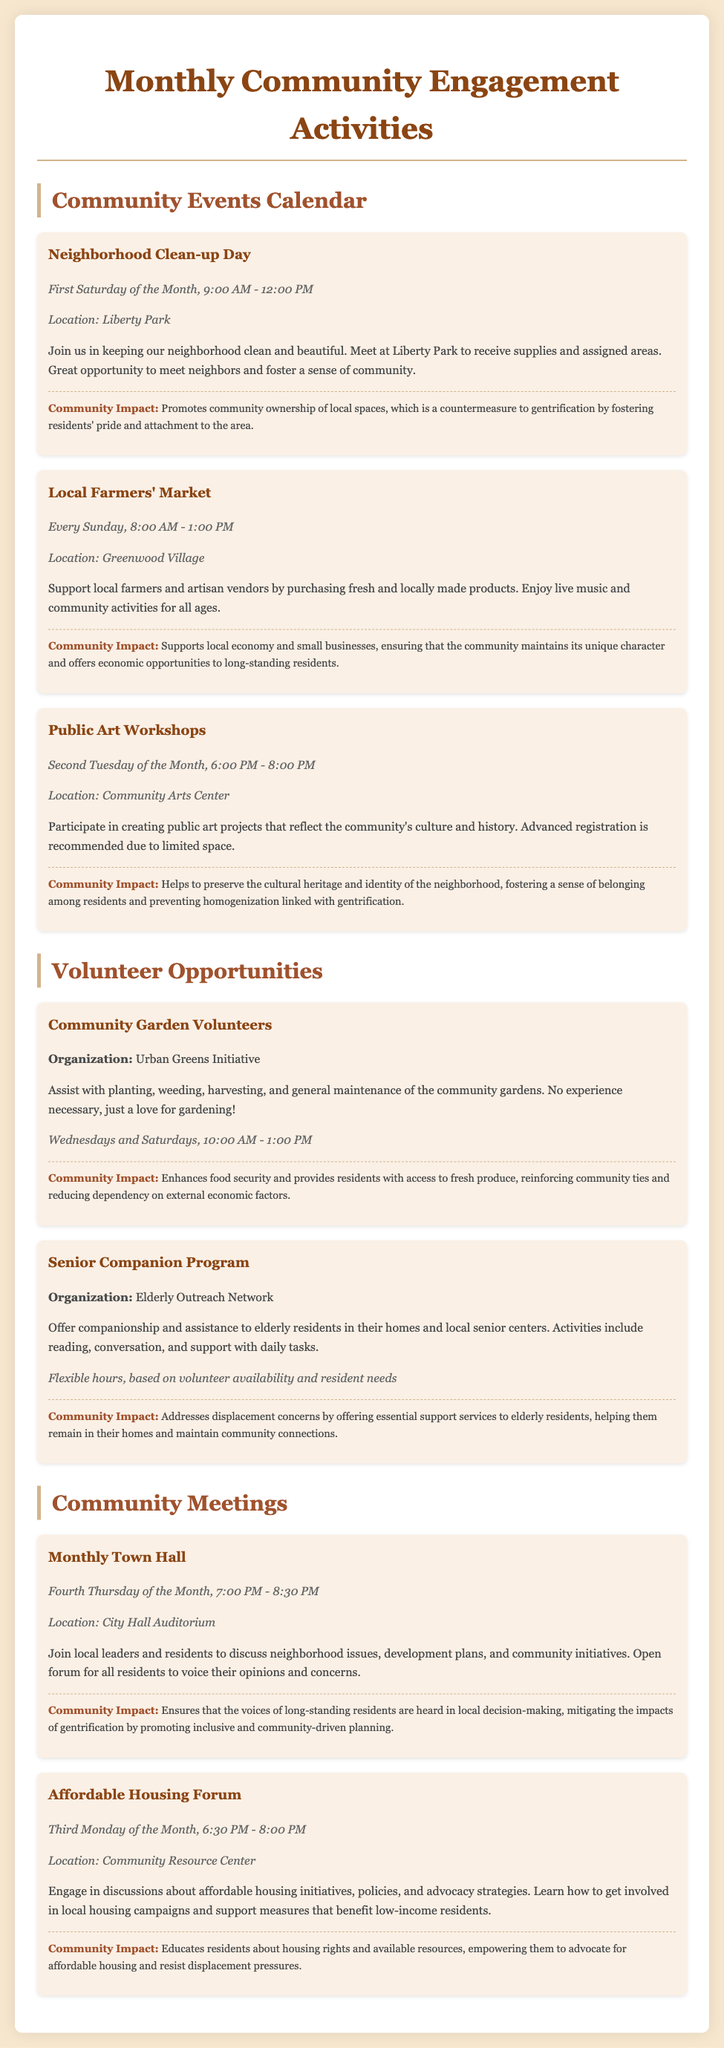What day is Neighborhood Clean-up Day? The document states that Neighborhood Clean-up Day is on the first Saturday of the month.
Answer: First Saturday of the Month Where is the Local Farmers' Market held? The document provides the location for the Local Farmers' Market as Greenwood Village.
Answer: Greenwood Village What time does the Monthly Town Hall start? According to the document, the Monthly Town Hall starts at 7:00 PM.
Answer: 7:00 PM What contribution does the Community Garden Volunteers opportunity make? The document specifies that Community Garden Volunteers enhance food security and provide access to fresh produce.
Answer: Enhances food security How often are Public Art Workshops held? The document indicates that Public Art Workshops are held on the second Tuesday of the month.
Answer: Second Tuesday of the Month What is the purpose of the Affordable Housing Forum? The document explains that the Affordable Housing Forum engages in discussions about affordable housing initiatives and policies.
Answer: Discussions about affordable housing initiatives What organization supports the Senior Companion Program? The document identifies the Elderly Outreach Network as the supporting organization for the Senior Companion Program.
Answer: Elderly Outreach Network What is the focus of the next Volunteer Opportunity? The document focuses on community gardening for the next Volunteer Opportunity.
Answer: Community Garden Volunteers What is the main objective of the Monthly Town Hall? The document states that the objective of the Monthly Town Hall is to discuss neighborhood issues and development plans.
Answer: Discuss neighborhood issues and development plans 